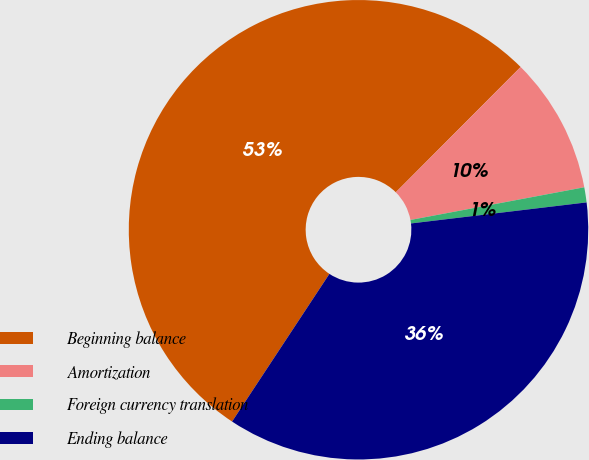Convert chart to OTSL. <chart><loc_0><loc_0><loc_500><loc_500><pie_chart><fcel>Beginning balance<fcel>Amortization<fcel>Foreign currency translation<fcel>Ending balance<nl><fcel>53.19%<fcel>9.57%<fcel>1.06%<fcel>36.17%<nl></chart> 